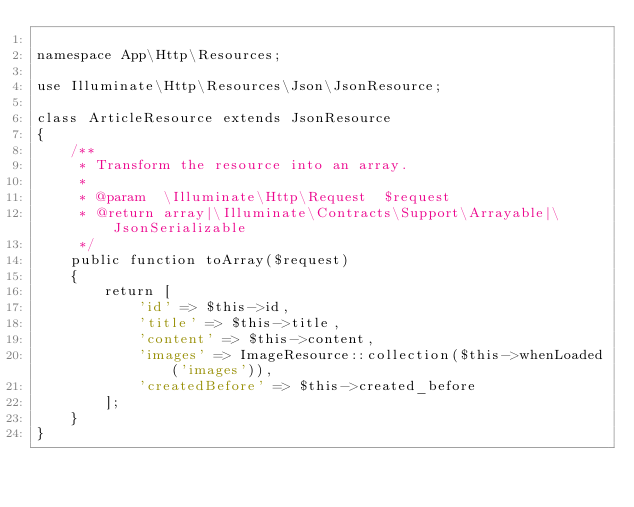<code> <loc_0><loc_0><loc_500><loc_500><_PHP_>
namespace App\Http\Resources;

use Illuminate\Http\Resources\Json\JsonResource;

class ArticleResource extends JsonResource
{
    /**
     * Transform the resource into an array.
     *
     * @param  \Illuminate\Http\Request  $request
     * @return array|\Illuminate\Contracts\Support\Arrayable|\JsonSerializable
     */
    public function toArray($request)
    {
        return [
            'id' => $this->id,
            'title' => $this->title,
            'content' => $this->content,
            'images' => ImageResource::collection($this->whenLoaded('images')),
            'createdBefore' => $this->created_before
        ];
    }
}
</code> 